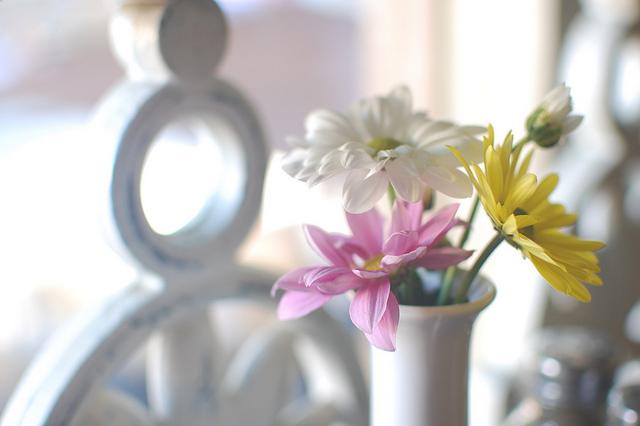What items in the image are alive?
Answer briefly. Flowers. Is this location a restaurant?
Quick response, please. No. Are all the flowers the same color?
Write a very short answer. No. 